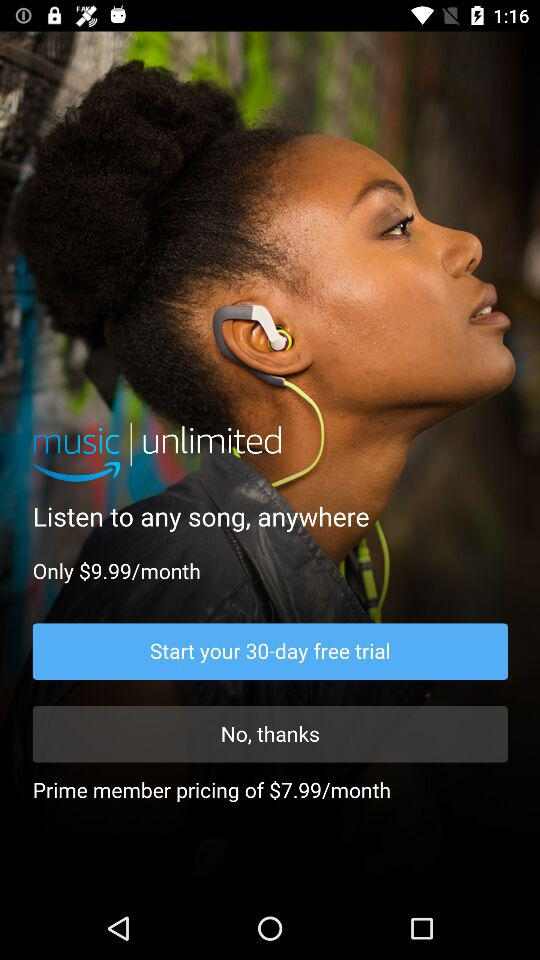What is the application name? The application name is "Amazon Music: Songs & Podcasts". 